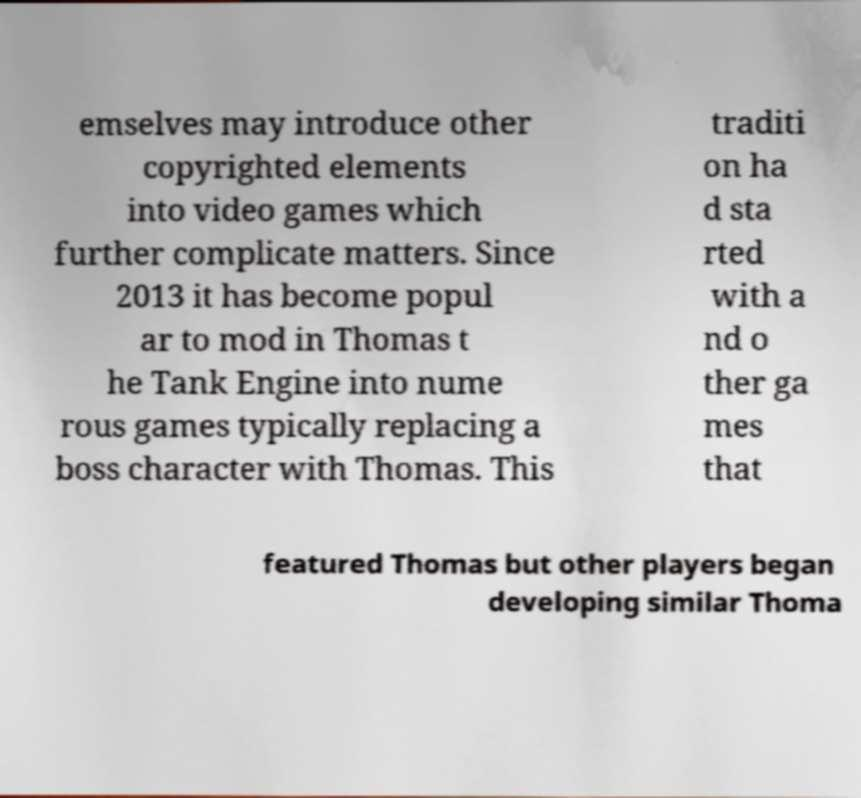I need the written content from this picture converted into text. Can you do that? emselves may introduce other copyrighted elements into video games which further complicate matters. Since 2013 it has become popul ar to mod in Thomas t he Tank Engine into nume rous games typically replacing a boss character with Thomas. This traditi on ha d sta rted with a nd o ther ga mes that featured Thomas but other players began developing similar Thoma 